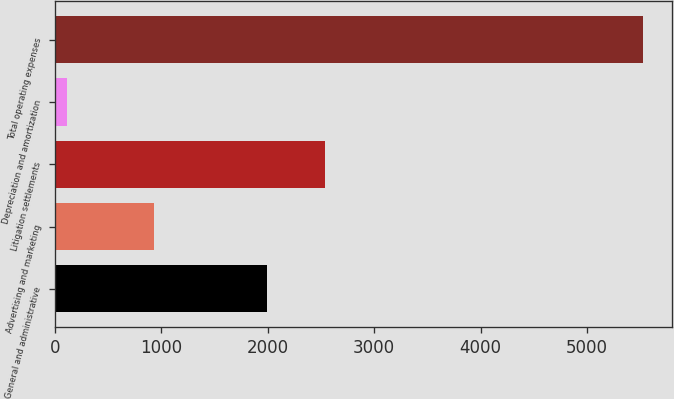Convert chart. <chart><loc_0><loc_0><loc_500><loc_500><bar_chart><fcel>General and administrative<fcel>Advertising and marketing<fcel>Litigation settlements<fcel>Depreciation and amortization<fcel>Total operating expenses<nl><fcel>1996<fcel>935<fcel>2537.4<fcel>112<fcel>5526<nl></chart> 